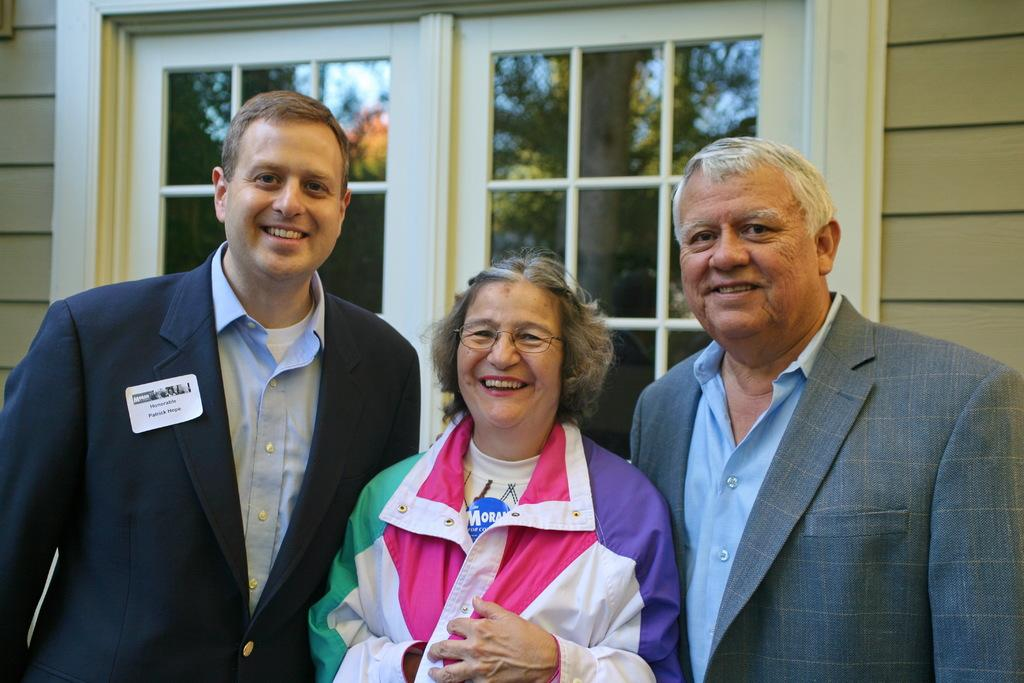How many people are in the image? There are three persons in the image. Can you describe one of the persons in the image? One woman is wearing spectacles. What can be seen in the background of the image? There is a building and a group of trees in the background of the image. What features does the building have? The building has doors. What type of things does the woman produce in the image? There is no indication in the image that the woman is producing any things. 